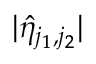<formula> <loc_0><loc_0><loc_500><loc_500>| \hat { \eta } _ { j _ { 1 } , j _ { 2 } } |</formula> 